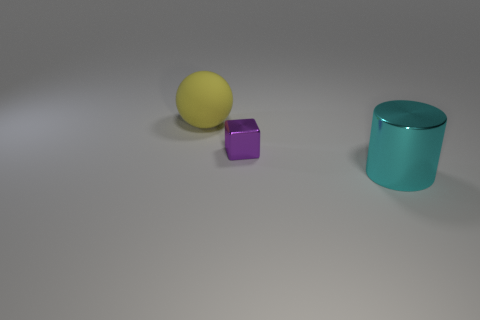Add 3 large rubber objects. How many objects exist? 6 Subtract all spheres. How many objects are left? 2 Subtract 1 blocks. How many blocks are left? 0 Add 2 small red objects. How many small red objects exist? 2 Subtract 1 purple cubes. How many objects are left? 2 Subtract all green spheres. Subtract all gray cubes. How many spheres are left? 1 Subtract all cylinders. Subtract all metal cubes. How many objects are left? 1 Add 2 yellow spheres. How many yellow spheres are left? 3 